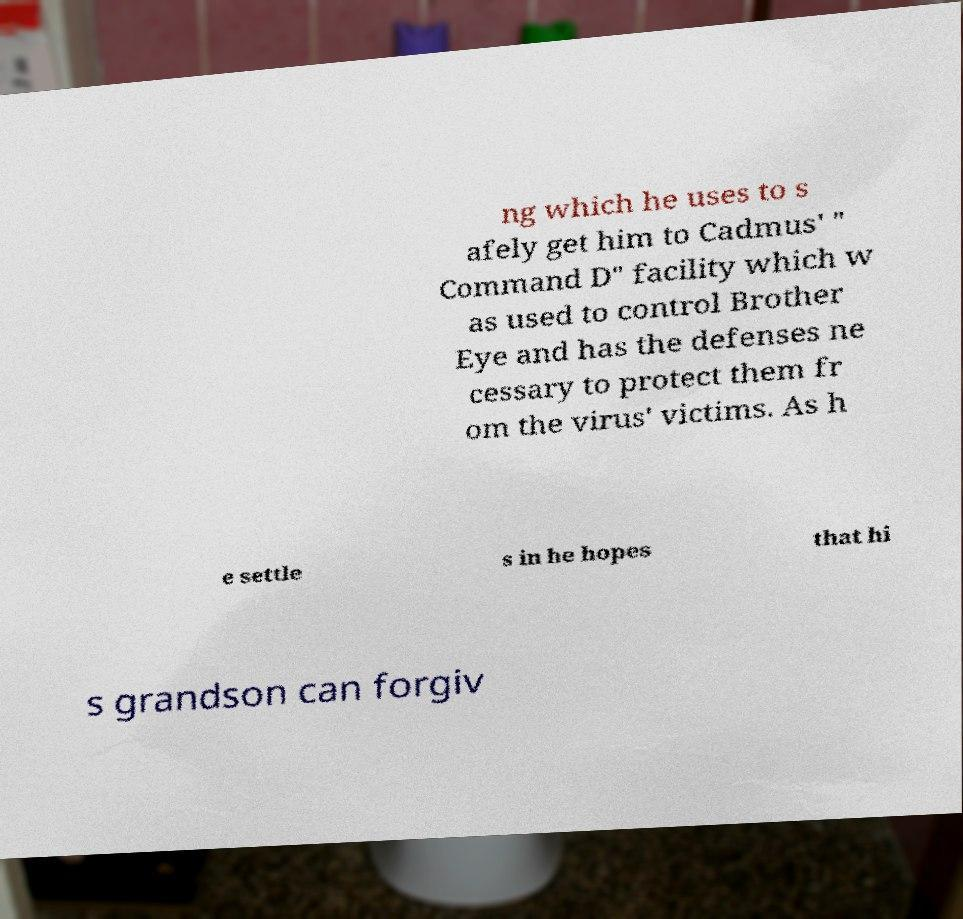I need the written content from this picture converted into text. Can you do that? ng which he uses to s afely get him to Cadmus' " Command D" facility which w as used to control Brother Eye and has the defenses ne cessary to protect them fr om the virus' victims. As h e settle s in he hopes that hi s grandson can forgiv 